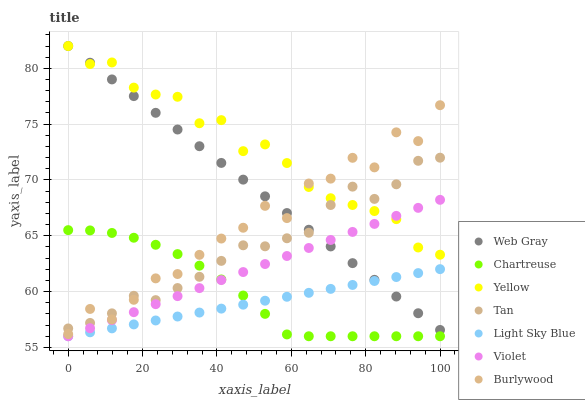Does Light Sky Blue have the minimum area under the curve?
Answer yes or no. Yes. Does Yellow have the maximum area under the curve?
Answer yes or no. Yes. Does Burlywood have the minimum area under the curve?
Answer yes or no. No. Does Burlywood have the maximum area under the curve?
Answer yes or no. No. Is Light Sky Blue the smoothest?
Answer yes or no. Yes. Is Burlywood the roughest?
Answer yes or no. Yes. Is Yellow the smoothest?
Answer yes or no. No. Is Yellow the roughest?
Answer yes or no. No. Does Chartreuse have the lowest value?
Answer yes or no. Yes. Does Burlywood have the lowest value?
Answer yes or no. No. Does Yellow have the highest value?
Answer yes or no. Yes. Does Burlywood have the highest value?
Answer yes or no. No. Is Chartreuse less than Yellow?
Answer yes or no. Yes. Is Burlywood greater than Violet?
Answer yes or no. Yes. Does Light Sky Blue intersect Web Gray?
Answer yes or no. Yes. Is Light Sky Blue less than Web Gray?
Answer yes or no. No. Is Light Sky Blue greater than Web Gray?
Answer yes or no. No. Does Chartreuse intersect Yellow?
Answer yes or no. No. 